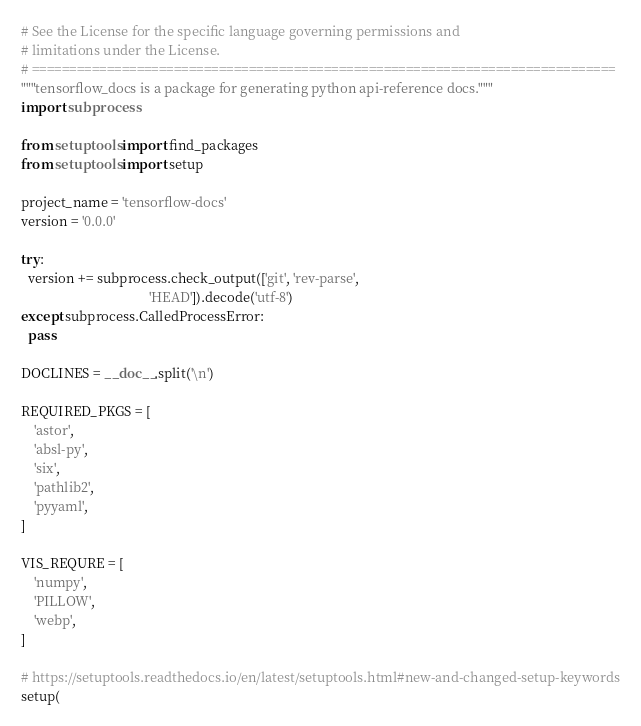<code> <loc_0><loc_0><loc_500><loc_500><_Python_># See the License for the specific language governing permissions and
# limitations under the License.
# ==============================================================================
"""tensorflow_docs is a package for generating python api-reference docs."""
import subprocess

from setuptools import find_packages
from setuptools import setup

project_name = 'tensorflow-docs'
version = '0.0.0'

try:
  version += subprocess.check_output(['git', 'rev-parse',
                                      'HEAD']).decode('utf-8')
except subprocess.CalledProcessError:
  pass

DOCLINES = __doc__.split('\n')

REQUIRED_PKGS = [
    'astor',
    'absl-py',
    'six',
    'pathlib2',
    'pyyaml',
]

VIS_REQURE = [
    'numpy',
    'PILLOW',
    'webp',
]

# https://setuptools.readthedocs.io/en/latest/setuptools.html#new-and-changed-setup-keywords
setup(</code> 